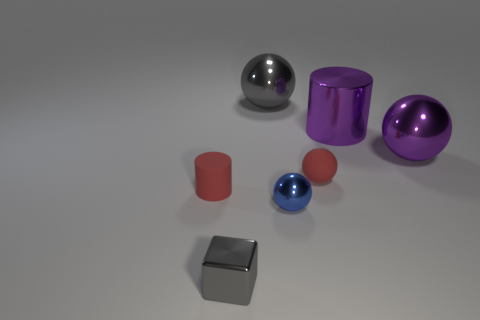Subtract all blue spheres. How many spheres are left? 3 Subtract all metallic spheres. How many spheres are left? 1 Subtract all brown spheres. Subtract all yellow cylinders. How many spheres are left? 4 Add 3 tiny yellow rubber cubes. How many objects exist? 10 Subtract all cylinders. How many objects are left? 5 Subtract all gray metal objects. Subtract all large purple shiny cubes. How many objects are left? 5 Add 3 blue shiny things. How many blue shiny things are left? 4 Add 5 blue rubber cylinders. How many blue rubber cylinders exist? 5 Subtract 0 purple cubes. How many objects are left? 7 